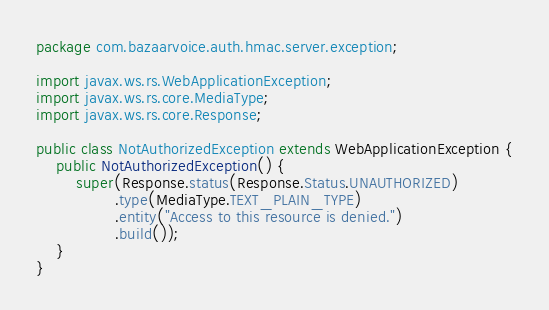<code> <loc_0><loc_0><loc_500><loc_500><_Java_>package com.bazaarvoice.auth.hmac.server.exception;

import javax.ws.rs.WebApplicationException;
import javax.ws.rs.core.MediaType;
import javax.ws.rs.core.Response;

public class NotAuthorizedException extends WebApplicationException {
    public NotAuthorizedException() {
        super(Response.status(Response.Status.UNAUTHORIZED)
                .type(MediaType.TEXT_PLAIN_TYPE)
                .entity("Access to this resource is denied.")
                .build());
    }
}
</code> 